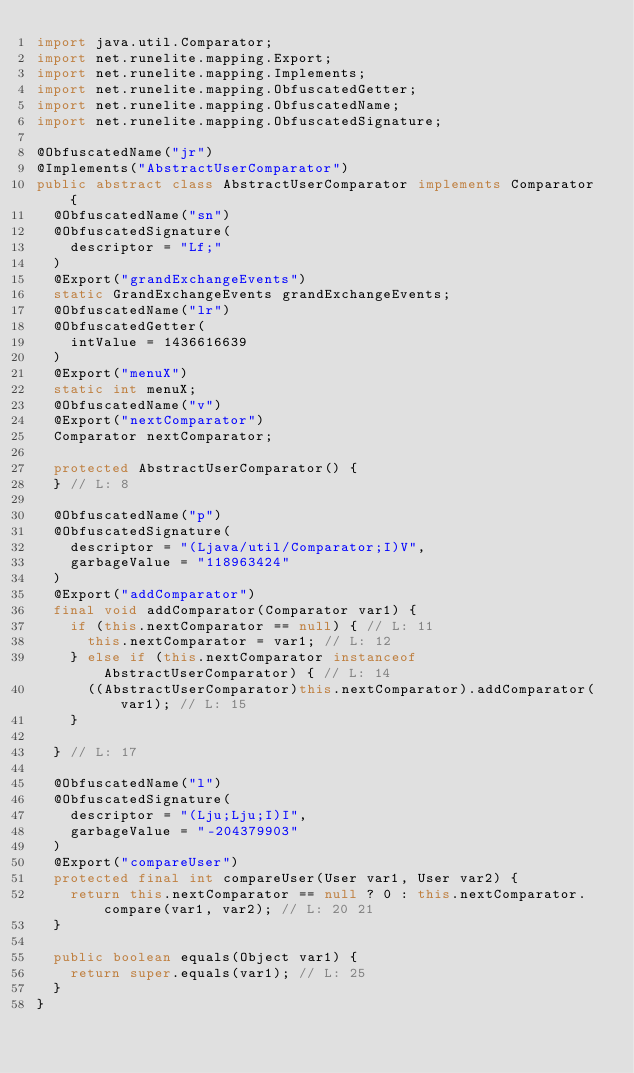<code> <loc_0><loc_0><loc_500><loc_500><_Java_>import java.util.Comparator;
import net.runelite.mapping.Export;
import net.runelite.mapping.Implements;
import net.runelite.mapping.ObfuscatedGetter;
import net.runelite.mapping.ObfuscatedName;
import net.runelite.mapping.ObfuscatedSignature;

@ObfuscatedName("jr")
@Implements("AbstractUserComparator")
public abstract class AbstractUserComparator implements Comparator {
	@ObfuscatedName("sn")
	@ObfuscatedSignature(
		descriptor = "Lf;"
	)
	@Export("grandExchangeEvents")
	static GrandExchangeEvents grandExchangeEvents;
	@ObfuscatedName("lr")
	@ObfuscatedGetter(
		intValue = 1436616639
	)
	@Export("menuX")
	static int menuX;
	@ObfuscatedName("v")
	@Export("nextComparator")
	Comparator nextComparator;

	protected AbstractUserComparator() {
	} // L: 8

	@ObfuscatedName("p")
	@ObfuscatedSignature(
		descriptor = "(Ljava/util/Comparator;I)V",
		garbageValue = "118963424"
	)
	@Export("addComparator")
	final void addComparator(Comparator var1) {
		if (this.nextComparator == null) { // L: 11
			this.nextComparator = var1; // L: 12
		} else if (this.nextComparator instanceof AbstractUserComparator) { // L: 14
			((AbstractUserComparator)this.nextComparator).addComparator(var1); // L: 15
		}

	} // L: 17

	@ObfuscatedName("l")
	@ObfuscatedSignature(
		descriptor = "(Lju;Lju;I)I",
		garbageValue = "-204379903"
	)
	@Export("compareUser")
	protected final int compareUser(User var1, User var2) {
		return this.nextComparator == null ? 0 : this.nextComparator.compare(var1, var2); // L: 20 21
	}

	public boolean equals(Object var1) {
		return super.equals(var1); // L: 25
	}
}
</code> 